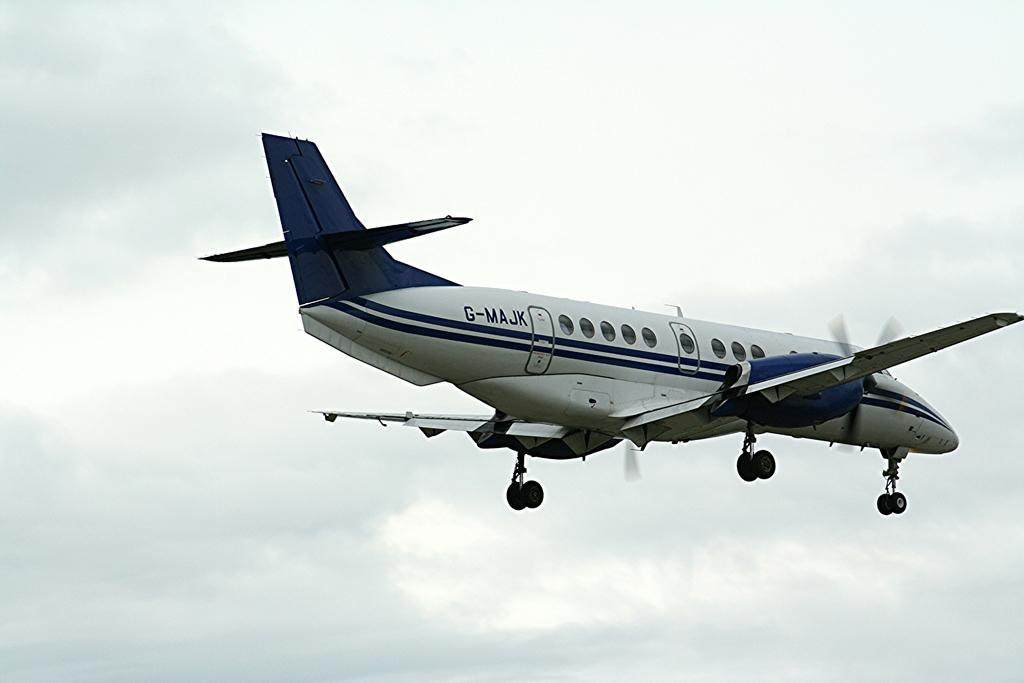<image>
Write a terse but informative summary of the picture. The type of jet being flown is a G-MAJK. 